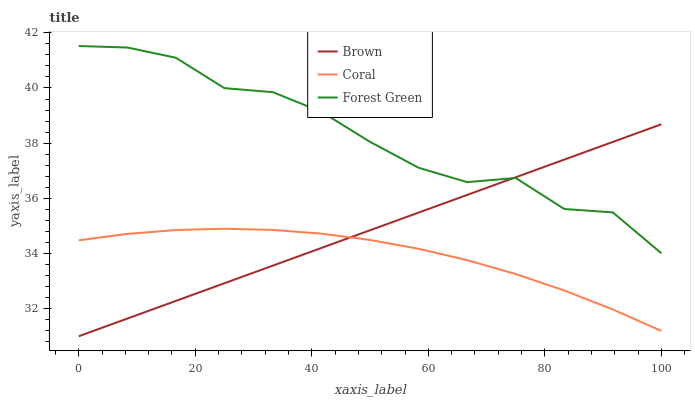Does Coral have the minimum area under the curve?
Answer yes or no. Yes. Does Forest Green have the maximum area under the curve?
Answer yes or no. Yes. Does Forest Green have the minimum area under the curve?
Answer yes or no. No. Does Coral have the maximum area under the curve?
Answer yes or no. No. Is Brown the smoothest?
Answer yes or no. Yes. Is Forest Green the roughest?
Answer yes or no. Yes. Is Coral the smoothest?
Answer yes or no. No. Is Coral the roughest?
Answer yes or no. No. Does Brown have the lowest value?
Answer yes or no. Yes. Does Coral have the lowest value?
Answer yes or no. No. Does Forest Green have the highest value?
Answer yes or no. Yes. Does Coral have the highest value?
Answer yes or no. No. Is Coral less than Forest Green?
Answer yes or no. Yes. Is Forest Green greater than Coral?
Answer yes or no. Yes. Does Coral intersect Brown?
Answer yes or no. Yes. Is Coral less than Brown?
Answer yes or no. No. Is Coral greater than Brown?
Answer yes or no. No. Does Coral intersect Forest Green?
Answer yes or no. No. 